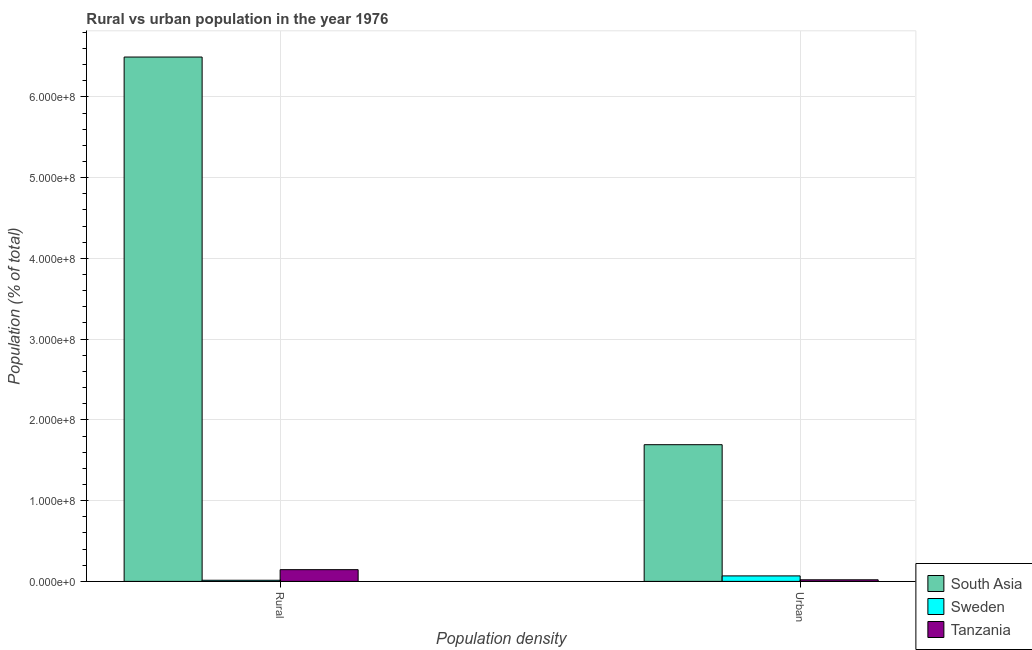How many different coloured bars are there?
Make the answer very short. 3. How many groups of bars are there?
Keep it short and to the point. 2. Are the number of bars per tick equal to the number of legend labels?
Provide a succinct answer. Yes. How many bars are there on the 2nd tick from the left?
Your answer should be compact. 3. What is the label of the 2nd group of bars from the left?
Offer a terse response. Urban. What is the urban population density in South Asia?
Offer a terse response. 1.69e+08. Across all countries, what is the maximum rural population density?
Provide a succinct answer. 6.49e+08. Across all countries, what is the minimum urban population density?
Give a very brief answer. 1.97e+06. In which country was the urban population density minimum?
Ensure brevity in your answer.  Tanzania. What is the total rural population density in the graph?
Your response must be concise. 6.65e+08. What is the difference between the rural population density in Sweden and that in South Asia?
Your answer should be compact. -6.48e+08. What is the difference between the urban population density in Tanzania and the rural population density in South Asia?
Give a very brief answer. -6.47e+08. What is the average urban population density per country?
Offer a very short reply. 5.93e+07. What is the difference between the urban population density and rural population density in Tanzania?
Provide a short and direct response. -1.26e+07. What is the ratio of the urban population density in Tanzania to that in South Asia?
Provide a short and direct response. 0.01. In how many countries, is the rural population density greater than the average rural population density taken over all countries?
Make the answer very short. 1. What does the 1st bar from the right in Rural represents?
Your answer should be very brief. Tanzania. How many bars are there?
Provide a short and direct response. 6. Are all the bars in the graph horizontal?
Your response must be concise. No. Does the graph contain any zero values?
Provide a succinct answer. No. Does the graph contain grids?
Provide a succinct answer. Yes. Where does the legend appear in the graph?
Ensure brevity in your answer.  Bottom right. What is the title of the graph?
Offer a terse response. Rural vs urban population in the year 1976. Does "Ghana" appear as one of the legend labels in the graph?
Your response must be concise. No. What is the label or title of the X-axis?
Provide a short and direct response. Population density. What is the label or title of the Y-axis?
Give a very brief answer. Population (% of total). What is the Population (% of total) of South Asia in Rural?
Your response must be concise. 6.49e+08. What is the Population (% of total) of Sweden in Rural?
Offer a very short reply. 1.41e+06. What is the Population (% of total) of Tanzania in Rural?
Offer a terse response. 1.45e+07. What is the Population (% of total) in South Asia in Urban?
Ensure brevity in your answer.  1.69e+08. What is the Population (% of total) of Sweden in Urban?
Offer a very short reply. 6.81e+06. What is the Population (% of total) in Tanzania in Urban?
Ensure brevity in your answer.  1.97e+06. Across all Population density, what is the maximum Population (% of total) in South Asia?
Your response must be concise. 6.49e+08. Across all Population density, what is the maximum Population (% of total) in Sweden?
Your response must be concise. 6.81e+06. Across all Population density, what is the maximum Population (% of total) of Tanzania?
Ensure brevity in your answer.  1.45e+07. Across all Population density, what is the minimum Population (% of total) of South Asia?
Keep it short and to the point. 1.69e+08. Across all Population density, what is the minimum Population (% of total) in Sweden?
Make the answer very short. 1.41e+06. Across all Population density, what is the minimum Population (% of total) in Tanzania?
Ensure brevity in your answer.  1.97e+06. What is the total Population (% of total) in South Asia in the graph?
Keep it short and to the point. 8.19e+08. What is the total Population (% of total) of Sweden in the graph?
Your answer should be very brief. 8.22e+06. What is the total Population (% of total) in Tanzania in the graph?
Offer a very short reply. 1.65e+07. What is the difference between the Population (% of total) of South Asia in Rural and that in Urban?
Your answer should be very brief. 4.80e+08. What is the difference between the Population (% of total) of Sweden in Rural and that in Urban?
Make the answer very short. -5.39e+06. What is the difference between the Population (% of total) of Tanzania in Rural and that in Urban?
Your answer should be compact. 1.26e+07. What is the difference between the Population (% of total) in South Asia in Rural and the Population (% of total) in Sweden in Urban?
Provide a short and direct response. 6.43e+08. What is the difference between the Population (% of total) of South Asia in Rural and the Population (% of total) of Tanzania in Urban?
Keep it short and to the point. 6.47e+08. What is the difference between the Population (% of total) in Sweden in Rural and the Population (% of total) in Tanzania in Urban?
Your answer should be very brief. -5.55e+05. What is the average Population (% of total) of South Asia per Population density?
Your answer should be compact. 4.09e+08. What is the average Population (% of total) of Sweden per Population density?
Provide a succinct answer. 4.11e+06. What is the average Population (% of total) of Tanzania per Population density?
Provide a short and direct response. 8.25e+06. What is the difference between the Population (% of total) in South Asia and Population (% of total) in Sweden in Rural?
Provide a short and direct response. 6.48e+08. What is the difference between the Population (% of total) in South Asia and Population (% of total) in Tanzania in Rural?
Make the answer very short. 6.35e+08. What is the difference between the Population (% of total) of Sweden and Population (% of total) of Tanzania in Rural?
Ensure brevity in your answer.  -1.31e+07. What is the difference between the Population (% of total) of South Asia and Population (% of total) of Sweden in Urban?
Give a very brief answer. 1.62e+08. What is the difference between the Population (% of total) of South Asia and Population (% of total) of Tanzania in Urban?
Your answer should be compact. 1.67e+08. What is the difference between the Population (% of total) of Sweden and Population (% of total) of Tanzania in Urban?
Provide a short and direct response. 4.84e+06. What is the ratio of the Population (% of total) in South Asia in Rural to that in Urban?
Provide a succinct answer. 3.84. What is the ratio of the Population (% of total) in Sweden in Rural to that in Urban?
Ensure brevity in your answer.  0.21. What is the ratio of the Population (% of total) of Tanzania in Rural to that in Urban?
Keep it short and to the point. 7.38. What is the difference between the highest and the second highest Population (% of total) in South Asia?
Make the answer very short. 4.80e+08. What is the difference between the highest and the second highest Population (% of total) in Sweden?
Keep it short and to the point. 5.39e+06. What is the difference between the highest and the second highest Population (% of total) of Tanzania?
Make the answer very short. 1.26e+07. What is the difference between the highest and the lowest Population (% of total) in South Asia?
Keep it short and to the point. 4.80e+08. What is the difference between the highest and the lowest Population (% of total) in Sweden?
Your answer should be very brief. 5.39e+06. What is the difference between the highest and the lowest Population (% of total) of Tanzania?
Ensure brevity in your answer.  1.26e+07. 